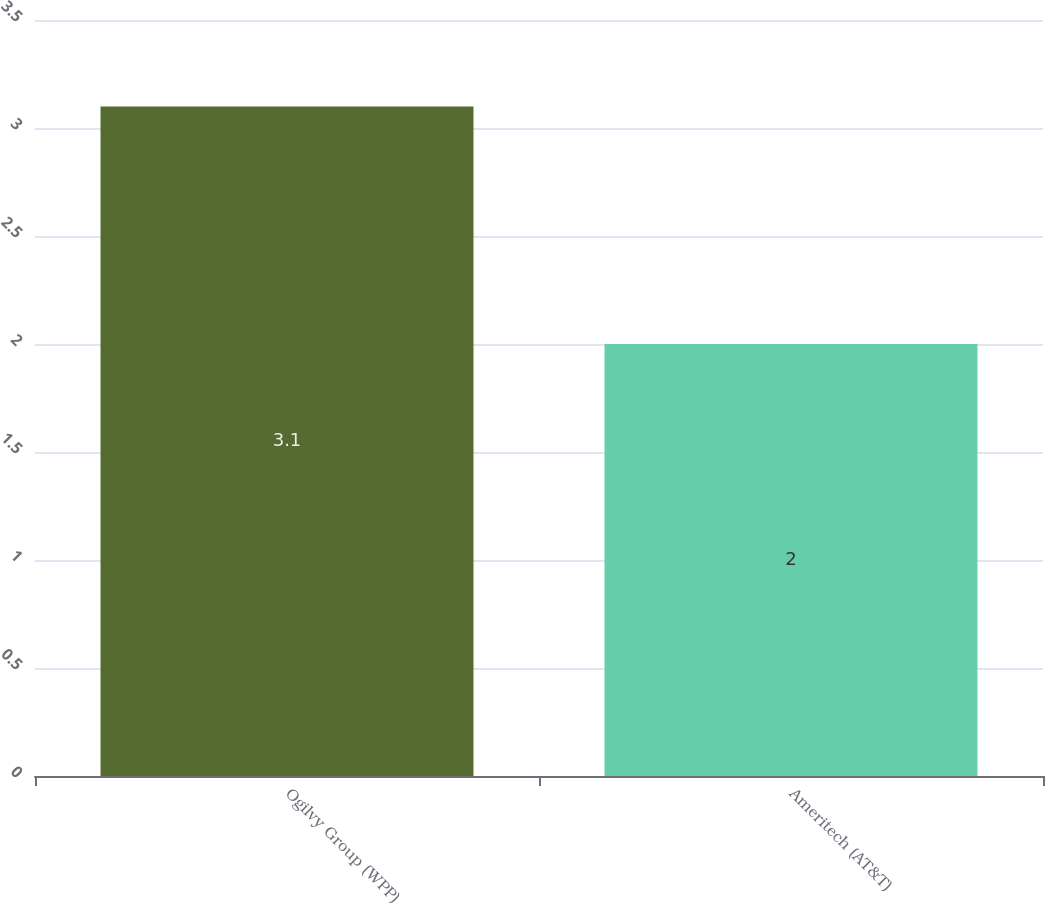Convert chart. <chart><loc_0><loc_0><loc_500><loc_500><bar_chart><fcel>Ogilvy Group (WPP)<fcel>Ameritech (AT&T)<nl><fcel>3.1<fcel>2<nl></chart> 